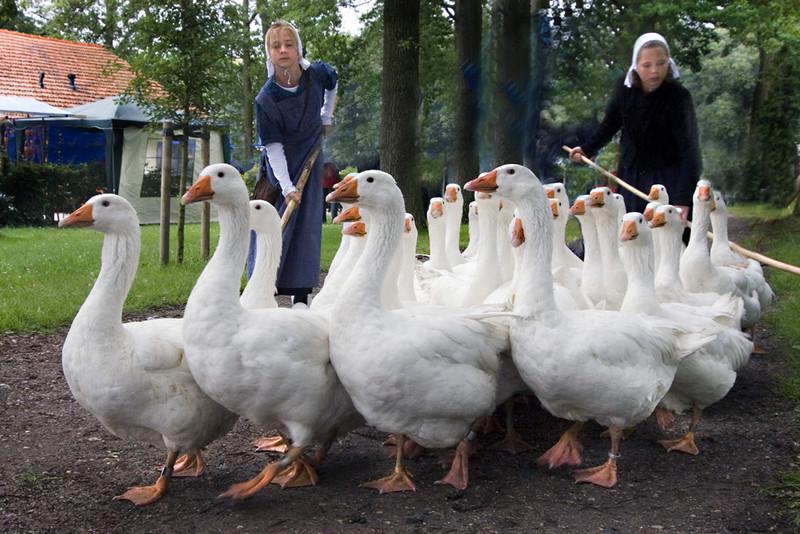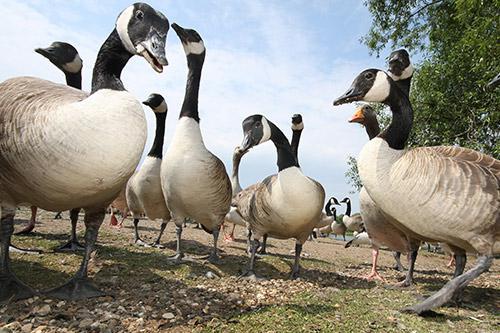The first image is the image on the left, the second image is the image on the right. Examine the images to the left and right. Is the description "At least one person is walking with the birds in one of the images." accurate? Answer yes or no. Yes. The first image is the image on the left, the second image is the image on the right. For the images displayed, is the sentence "An image shows a girl in a head covering standing behind a flock of white birds and holding a stick." factually correct? Answer yes or no. Yes. 